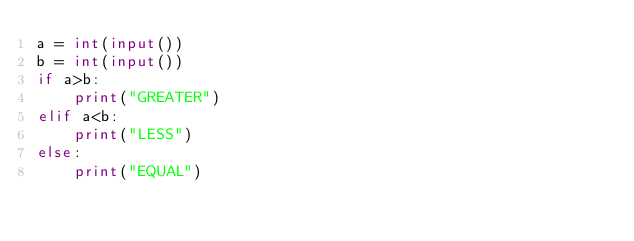<code> <loc_0><loc_0><loc_500><loc_500><_Python_>a = int(input())
b = int(input())
if a>b:
    print("GREATER")
elif a<b:
    print("LESS")
else:
    print("EQUAL")
</code> 